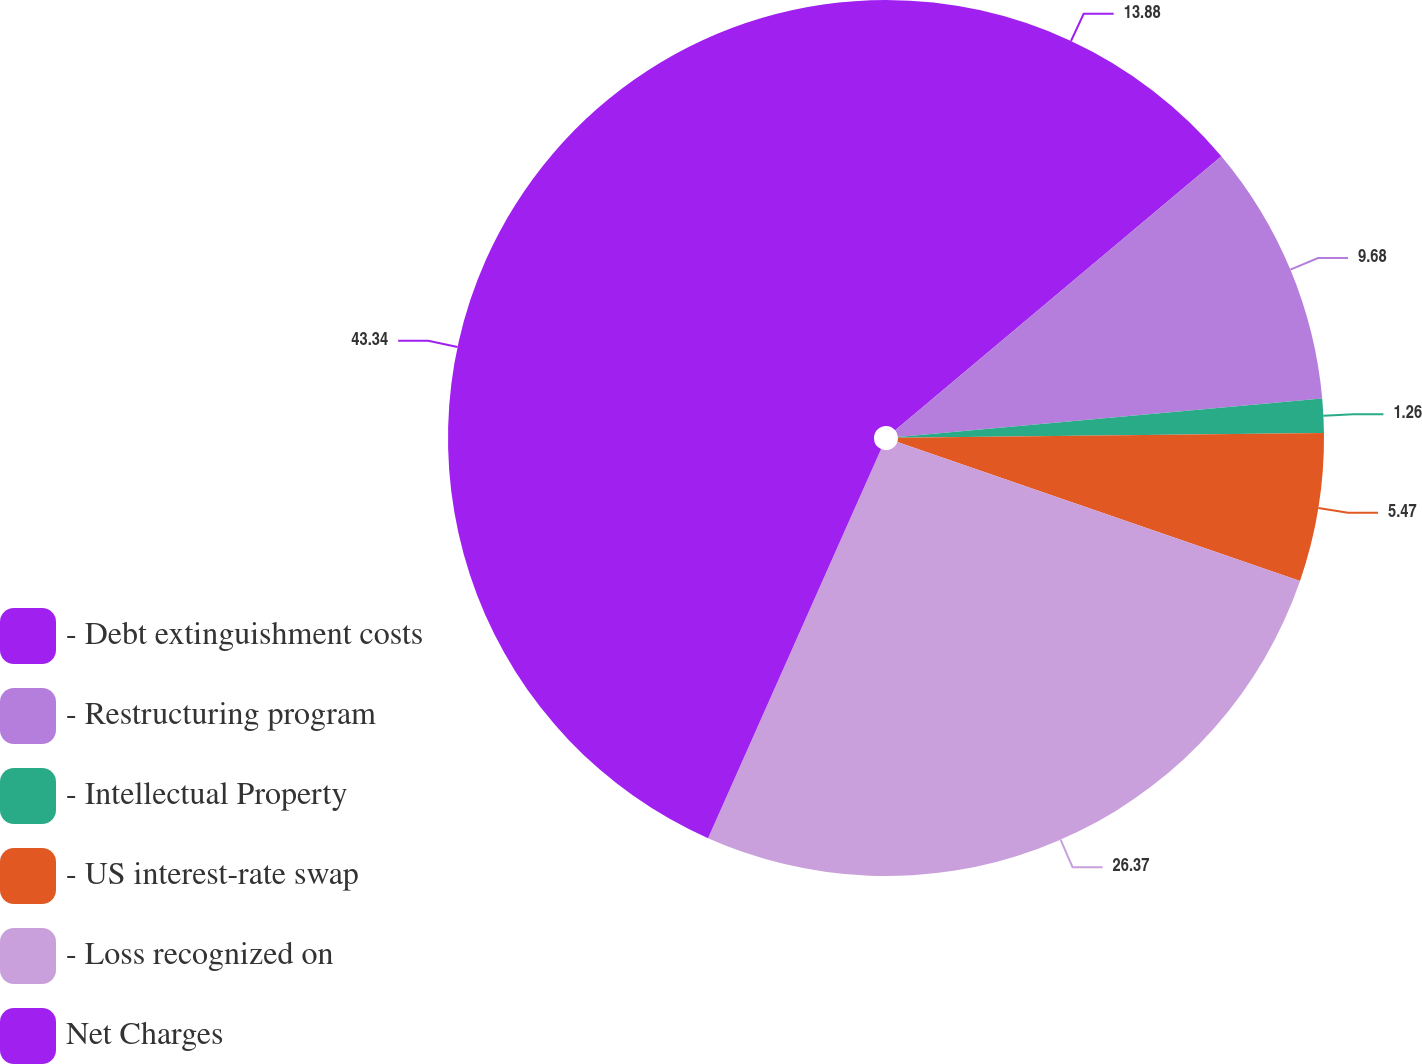Convert chart to OTSL. <chart><loc_0><loc_0><loc_500><loc_500><pie_chart><fcel>- Debt extinguishment costs<fcel>- Restructuring program<fcel>- Intellectual Property<fcel>- US interest-rate swap<fcel>- Loss recognized on<fcel>Net Charges<nl><fcel>13.88%<fcel>9.68%<fcel>1.26%<fcel>5.47%<fcel>26.37%<fcel>43.34%<nl></chart> 